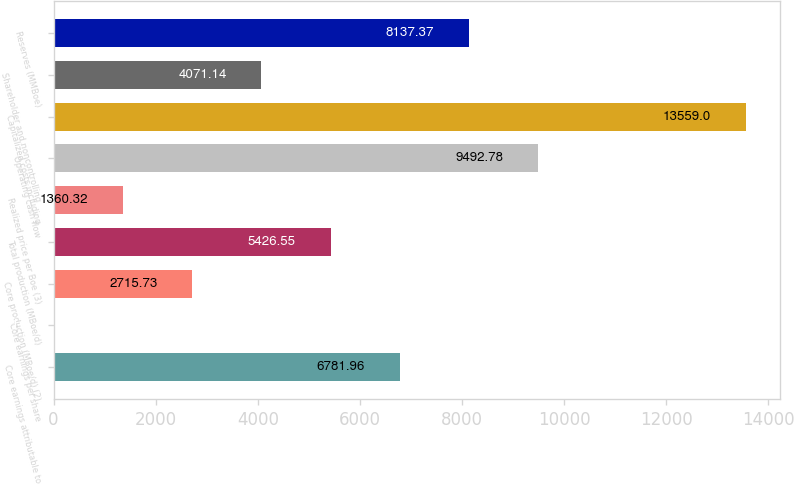Convert chart. <chart><loc_0><loc_0><loc_500><loc_500><bar_chart><fcel>Core earnings attributable to<fcel>Core earnings per share<fcel>Core production (MBoe/d) (2)<fcel>Total production (MBoe/d)<fcel>Realized price per Boe (3)<fcel>Operating cash flow<fcel>Capitalized costs including<fcel>Shareholder and noncontrolling<fcel>Reserves (MMBoe)<nl><fcel>6781.96<fcel>4.91<fcel>2715.73<fcel>5426.55<fcel>1360.32<fcel>9492.78<fcel>13559<fcel>4071.14<fcel>8137.37<nl></chart> 